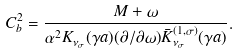<formula> <loc_0><loc_0><loc_500><loc_500>C _ { b } ^ { 2 } = \frac { M + \omega } { \alpha ^ { 2 } K _ { \nu _ { \sigma } } ( \gamma a ) ( \partial / \partial \omega ) \bar { K } _ { \nu _ { \sigma } } ^ { ( 1 , \sigma ) } ( \gamma a ) } .</formula> 